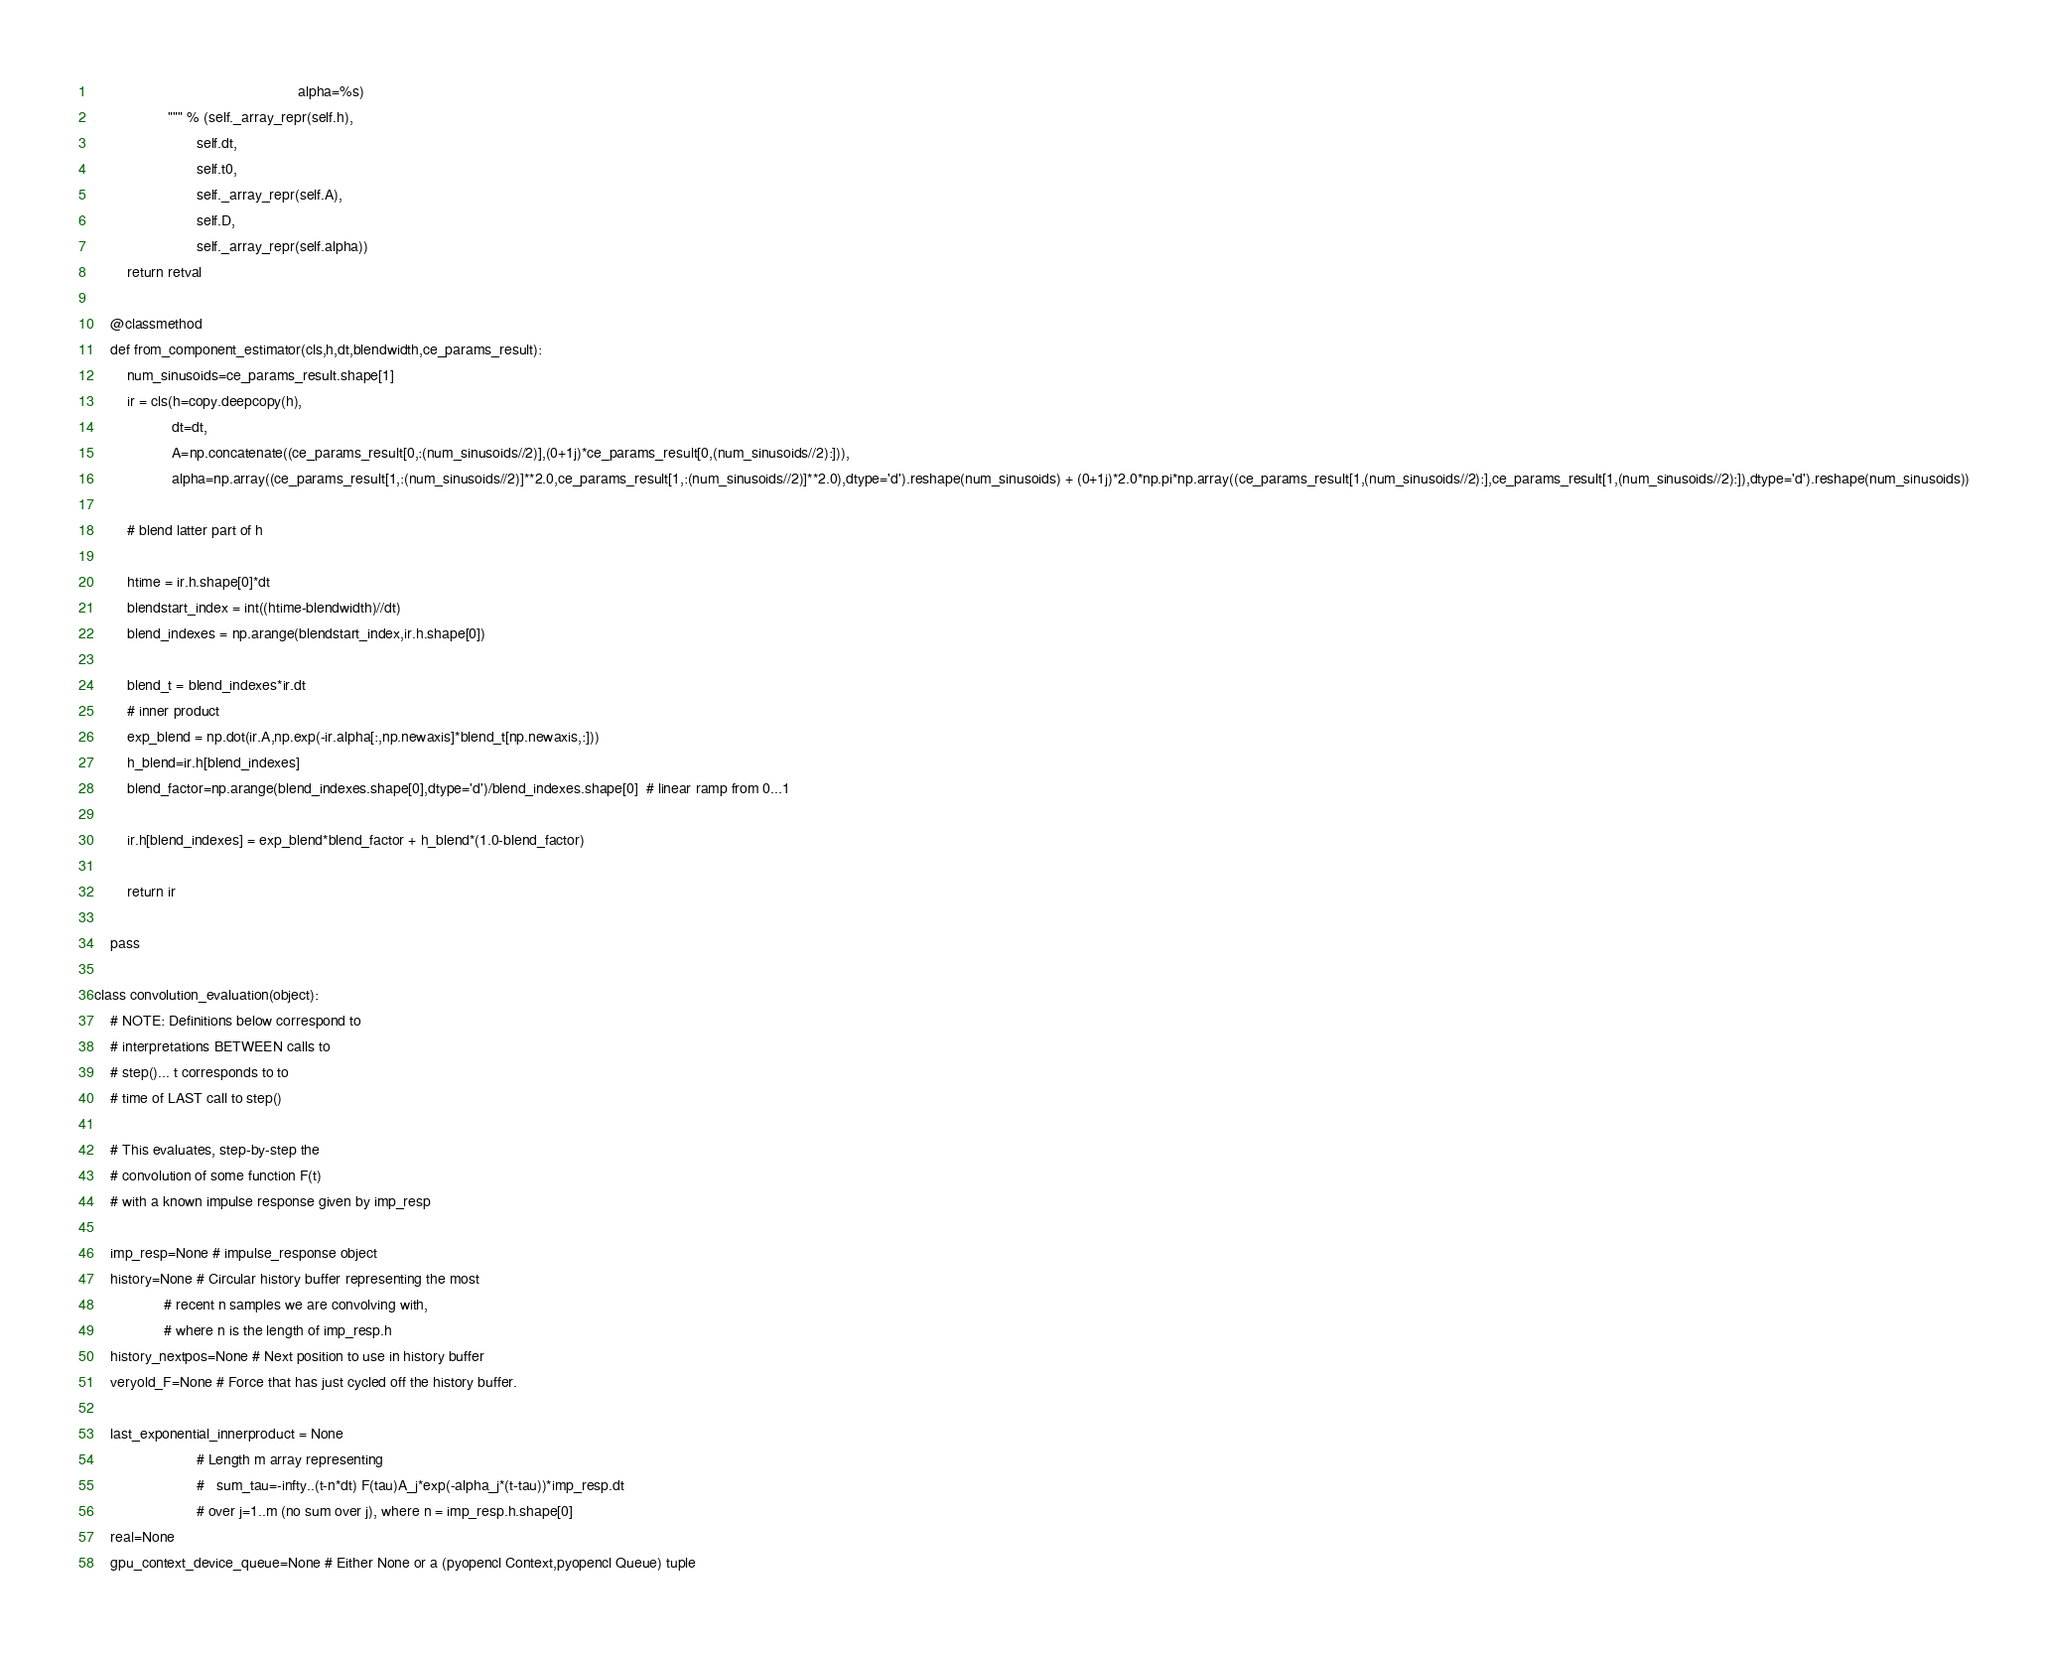Convert code to text. <code><loc_0><loc_0><loc_500><loc_500><_Cython_>                                                  alpha=%s)
                  """ % (self._array_repr(self.h),
                         self.dt,
                         self.t0,
                         self._array_repr(self.A),
                         self.D,
                         self._array_repr(self.alpha))
        return retval
    
    @classmethod
    def from_component_estimator(cls,h,dt,blendwidth,ce_params_result):
        num_sinusoids=ce_params_result.shape[1]
        ir = cls(h=copy.deepcopy(h),
                   dt=dt,
                   A=np.concatenate((ce_params_result[0,:(num_sinusoids//2)],(0+1j)*ce_params_result[0,(num_sinusoids//2):])),
                   alpha=np.array((ce_params_result[1,:(num_sinusoids//2)]**2.0,ce_params_result[1,:(num_sinusoids//2)]**2.0),dtype='d').reshape(num_sinusoids) + (0+1j)*2.0*np.pi*np.array((ce_params_result[1,(num_sinusoids//2):],ce_params_result[1,(num_sinusoids//2):]),dtype='d').reshape(num_sinusoids))

        # blend latter part of h 

        htime = ir.h.shape[0]*dt
        blendstart_index = int((htime-blendwidth)//dt)
        blend_indexes = np.arange(blendstart_index,ir.h.shape[0])
        
        blend_t = blend_indexes*ir.dt
        # inner product
        exp_blend = np.dot(ir.A,np.exp(-ir.alpha[:,np.newaxis]*blend_t[np.newaxis,:]))
        h_blend=ir.h[blend_indexes]
        blend_factor=np.arange(blend_indexes.shape[0],dtype='d')/blend_indexes.shape[0]  # linear ramp from 0...1
        
        ir.h[blend_indexes] = exp_blend*blend_factor + h_blend*(1.0-blend_factor)
        
        return ir
        
    pass 

class convolution_evaluation(object):
    # NOTE: Definitions below correspond to
    # interpretations BETWEEN calls to
    # step()... t corresponds to to
    # time of LAST call to step()

    # This evaluates, step-by-step the
    # convolution of some function F(t)
    # with a known impulse response given by imp_resp
    
    imp_resp=None # impulse_response object
    history=None # Circular history buffer representing the most
                 # recent n samples we are convolving with,
                 # where n is the length of imp_resp.h
    history_nextpos=None # Next position to use in history buffer
    veryold_F=None # Force that has just cycled off the history buffer.
    
    last_exponential_innerproduct = None
                         # Length m array representing             
                         #   sum_tau=-infty..(t-n*dt) F(tau)A_j*exp(-alpha_j*(t-tau))*imp_resp.dt
                         # over j=1..m (no sum over j), where n = imp_resp.h.shape[0]
    real=None
    gpu_context_device_queue=None # Either None or a (pyopencl Context,pyopencl Queue) tuple</code> 